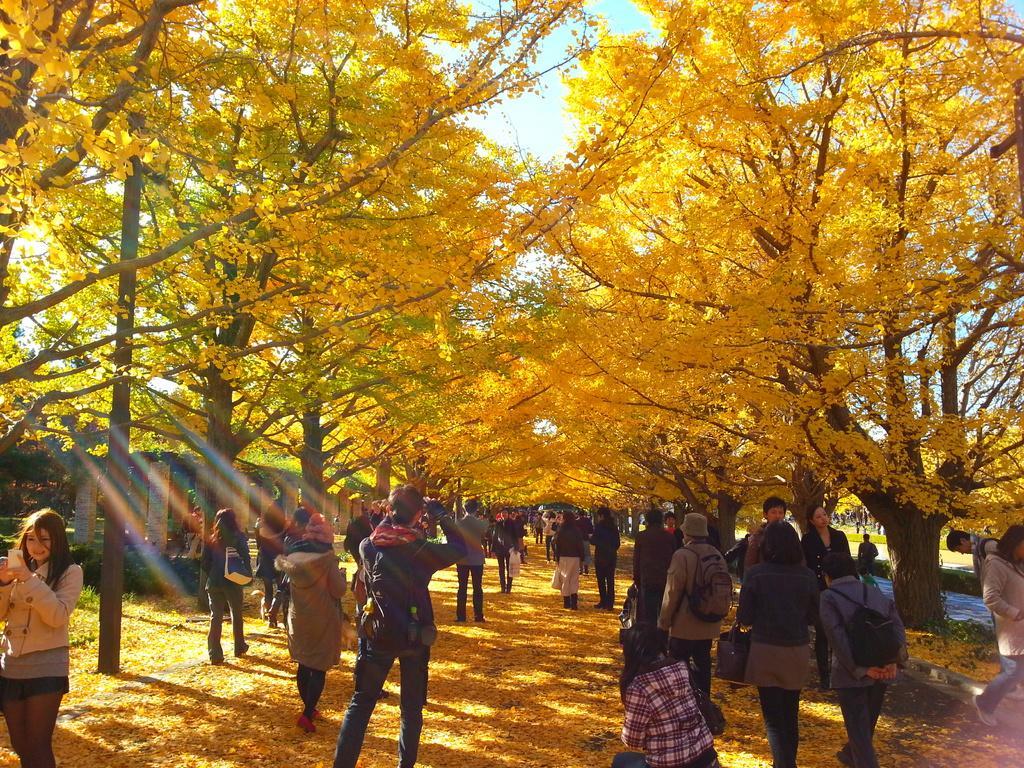Describe this image in one or two sentences. In this image I can see the group of people with different color dresses. I can see few people with the bags and one person is wearing the hat. In the background I can see many trees and the sky. 